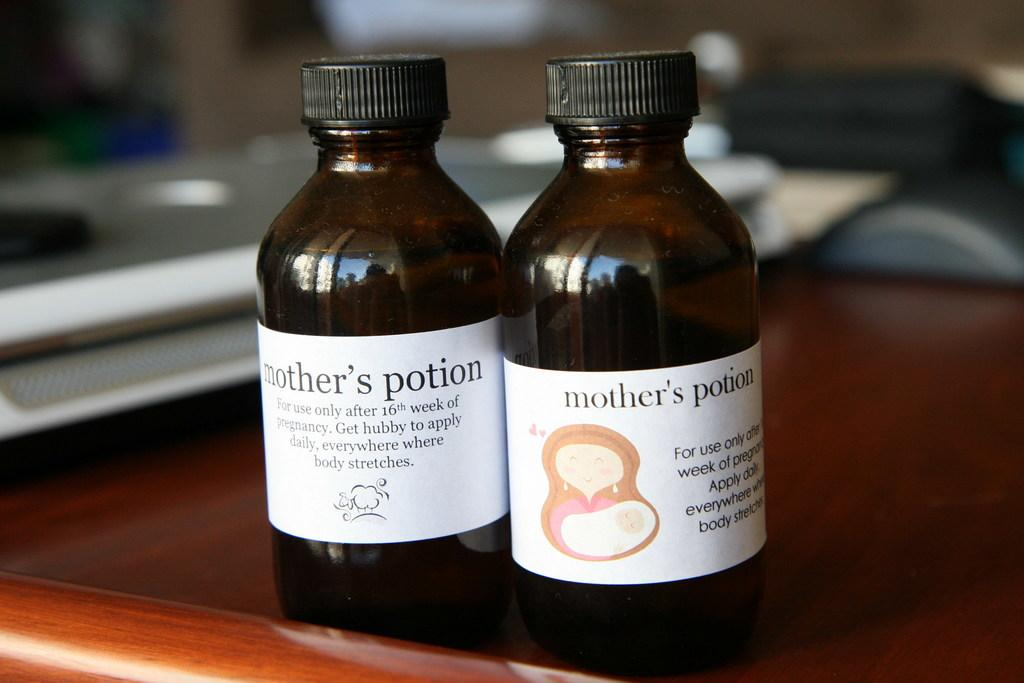<image>
Describe the image concisely. 2 bottles of medicine called mothers potion on the counter 